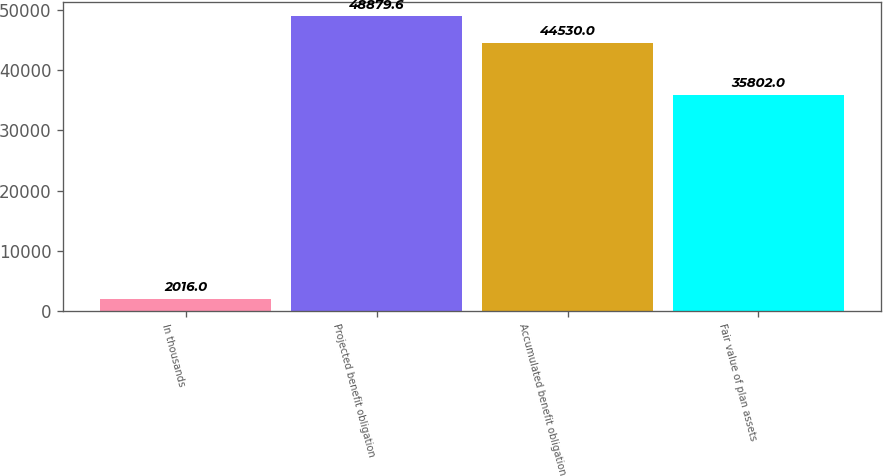Convert chart to OTSL. <chart><loc_0><loc_0><loc_500><loc_500><bar_chart><fcel>In thousands<fcel>Projected benefit obligation<fcel>Accumulated benefit obligation<fcel>Fair value of plan assets<nl><fcel>2016<fcel>48879.6<fcel>44530<fcel>35802<nl></chart> 